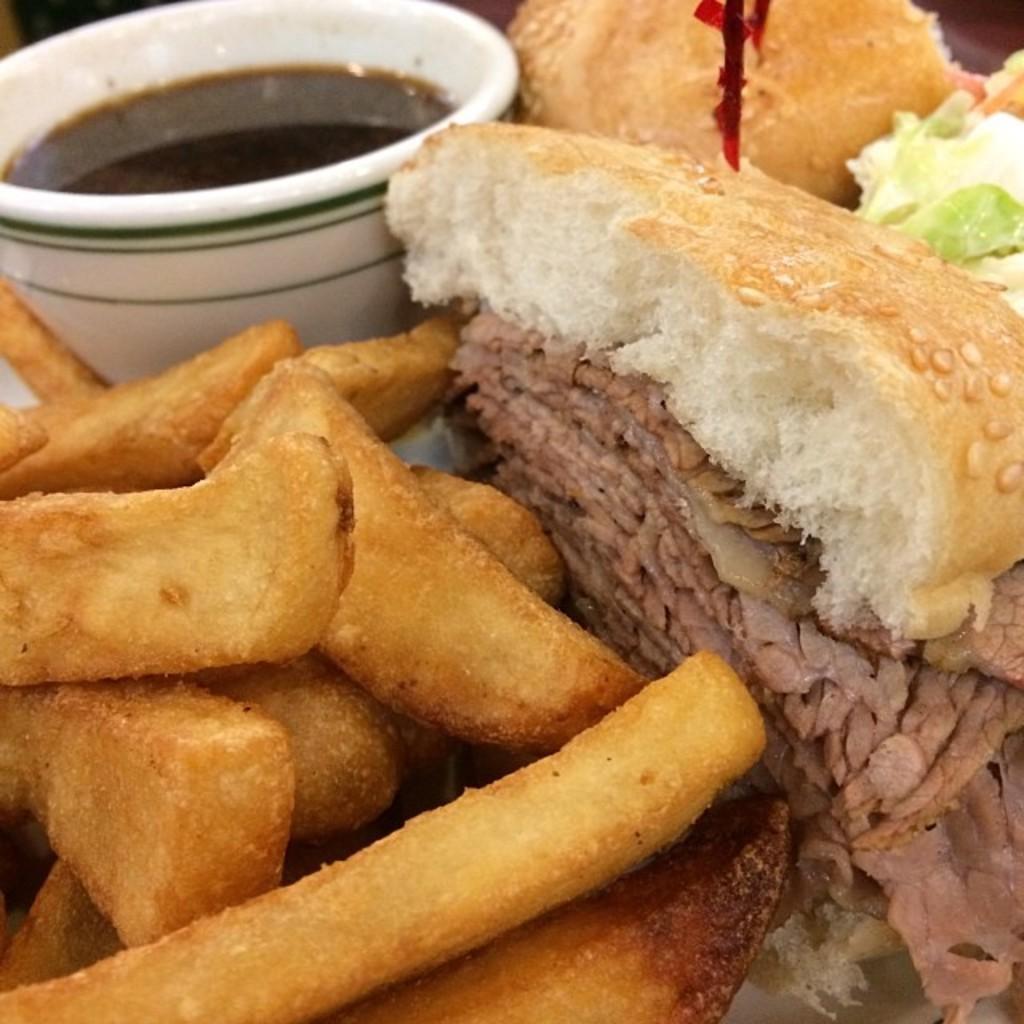Could you give a brief overview of what you see in this image? This picture shows food in the plate and we see sauce in the plate and we see french fries in the plate. 